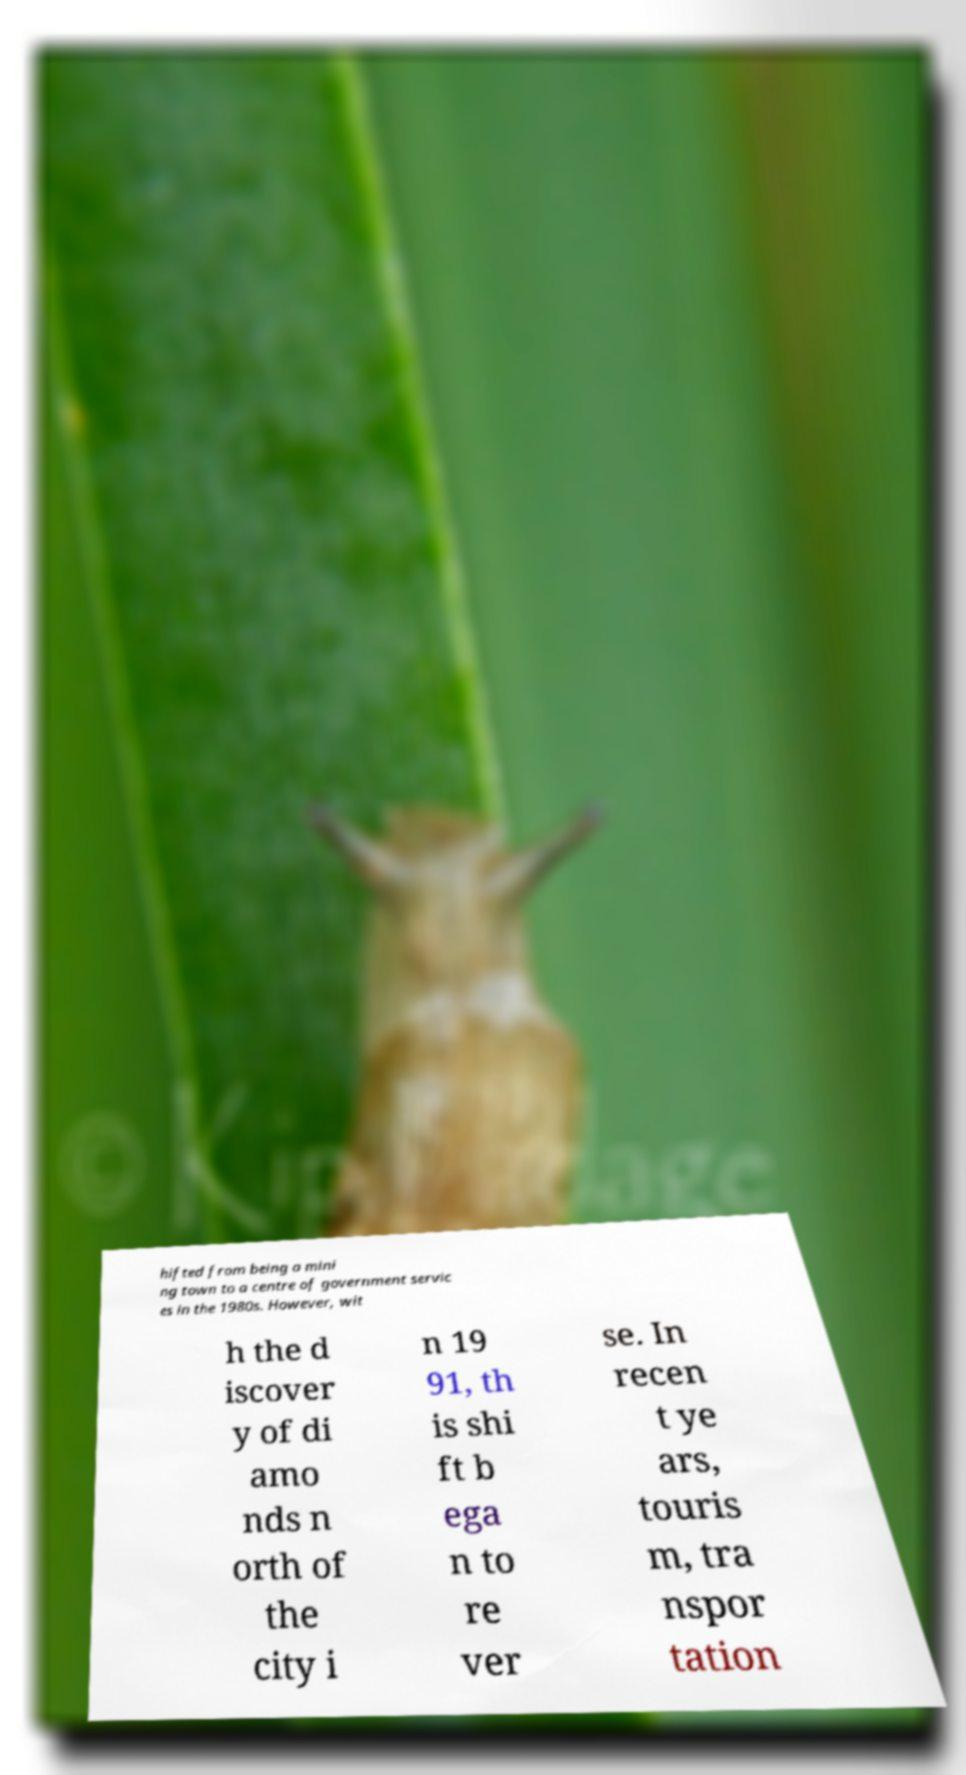Please read and relay the text visible in this image. What does it say? hifted from being a mini ng town to a centre of government servic es in the 1980s. However, wit h the d iscover y of di amo nds n orth of the city i n 19 91, th is shi ft b ega n to re ver se. In recen t ye ars, touris m, tra nspor tation 